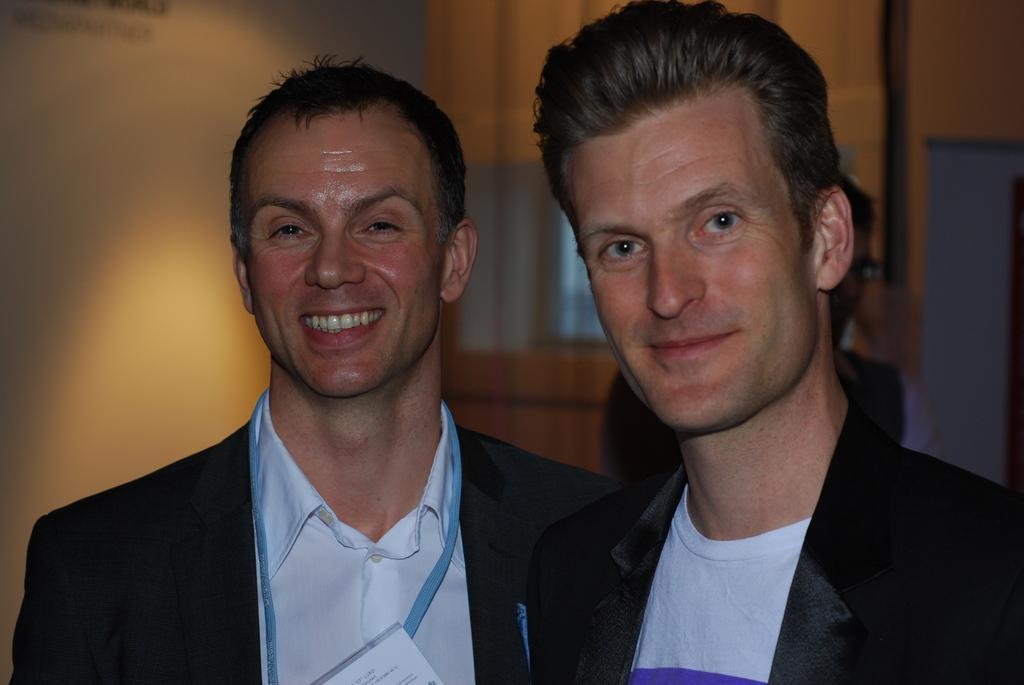Can you describe this image briefly? In this image I can see two persons and they are wearing black blazer, white shirt. Background I can see a wooden wall and the wall is brown color. 